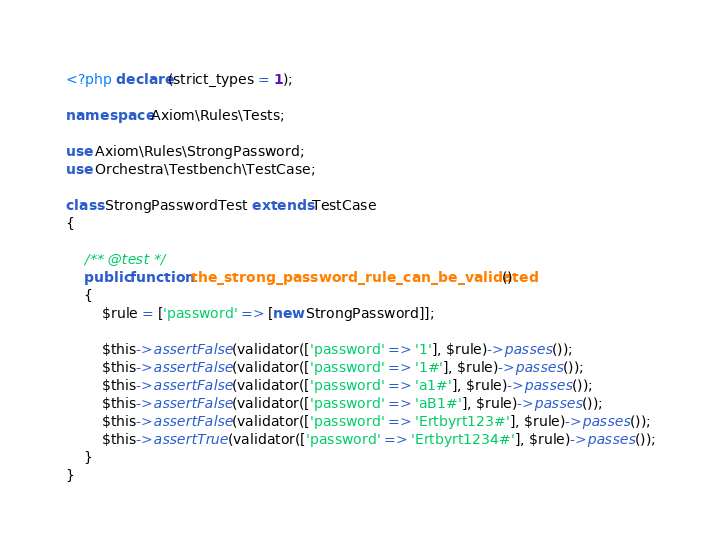<code> <loc_0><loc_0><loc_500><loc_500><_PHP_><?php declare(strict_types = 1);

namespace Axiom\Rules\Tests;

use Axiom\Rules\StrongPassword;
use Orchestra\Testbench\TestCase;

class StrongPasswordTest extends TestCase
{

    /** @test */
    public function the_strong_password_rule_can_be_validated()
    {
        $rule = ['password' => [new StrongPassword]];

        $this->assertFalse(validator(['password' => '1'], $rule)->passes());
        $this->assertFalse(validator(['password' => '1#'], $rule)->passes());
        $this->assertFalse(validator(['password' => 'a1#'], $rule)->passes());
        $this->assertFalse(validator(['password' => 'aB1#'], $rule)->passes());
        $this->assertFalse(validator(['password' => 'Ertbyrt123#'], $rule)->passes());
        $this->assertTrue(validator(['password' => 'Ertbyrt1234#'], $rule)->passes());
    }
}
</code> 